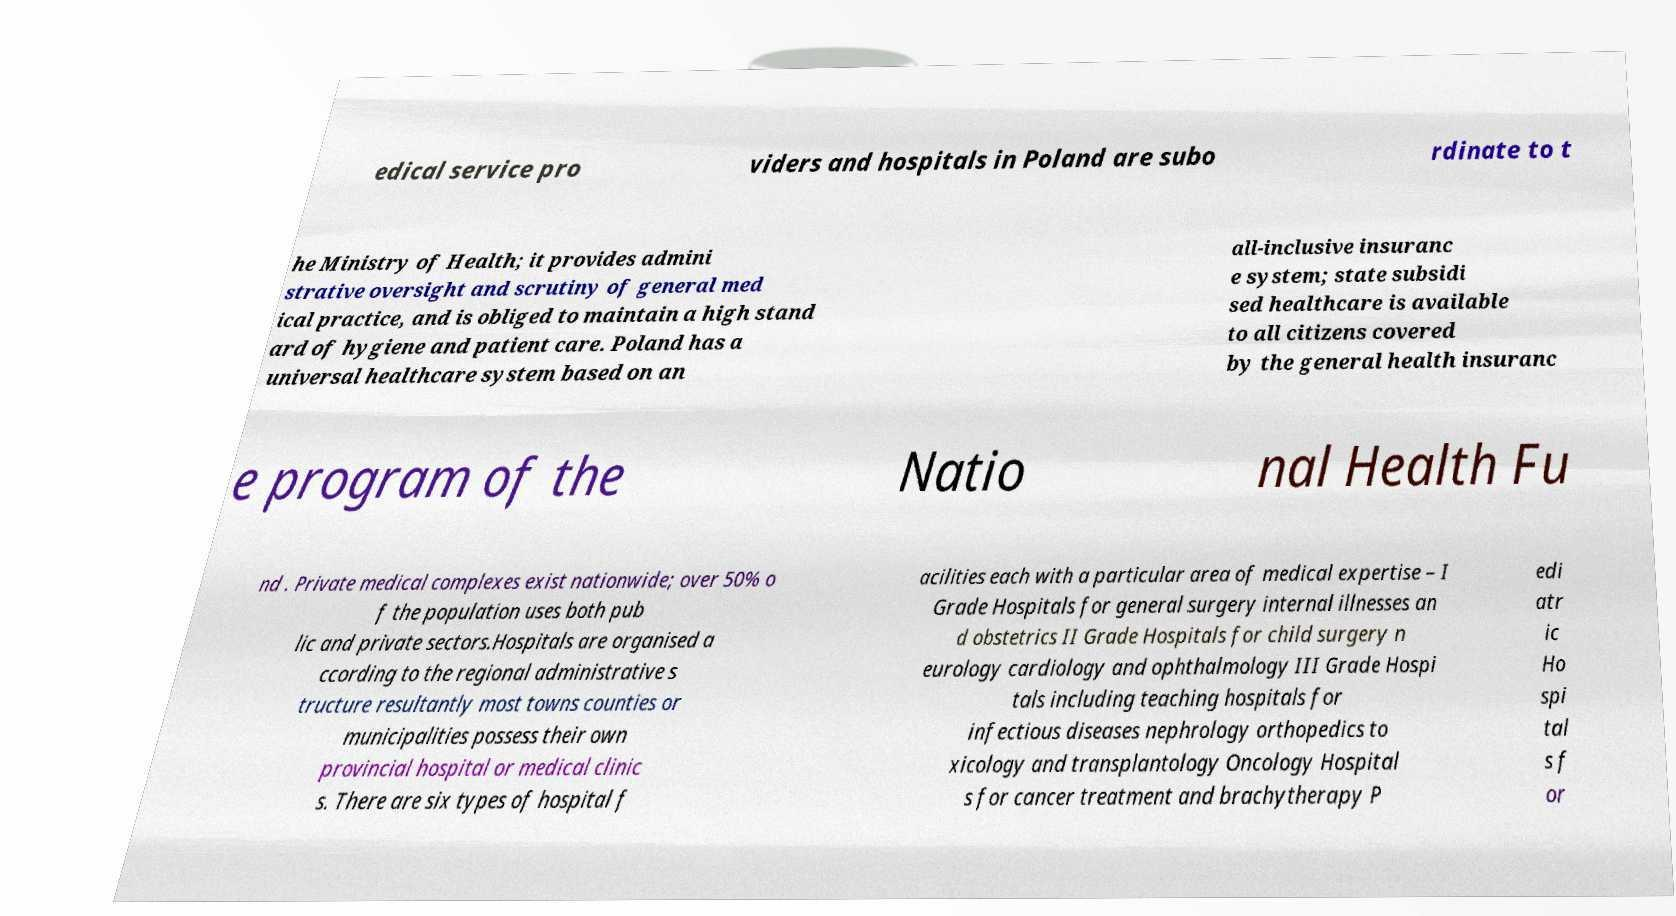For documentation purposes, I need the text within this image transcribed. Could you provide that? edical service pro viders and hospitals in Poland are subo rdinate to t he Ministry of Health; it provides admini strative oversight and scrutiny of general med ical practice, and is obliged to maintain a high stand ard of hygiene and patient care. Poland has a universal healthcare system based on an all-inclusive insuranc e system; state subsidi sed healthcare is available to all citizens covered by the general health insuranc e program of the Natio nal Health Fu nd . Private medical complexes exist nationwide; over 50% o f the population uses both pub lic and private sectors.Hospitals are organised a ccording to the regional administrative s tructure resultantly most towns counties or municipalities possess their own provincial hospital or medical clinic s. There are six types of hospital f acilities each with a particular area of medical expertise – I Grade Hospitals for general surgery internal illnesses an d obstetrics II Grade Hospitals for child surgery n eurology cardiology and ophthalmology III Grade Hospi tals including teaching hospitals for infectious diseases nephrology orthopedics to xicology and transplantology Oncology Hospital s for cancer treatment and brachytherapy P edi atr ic Ho spi tal s f or 